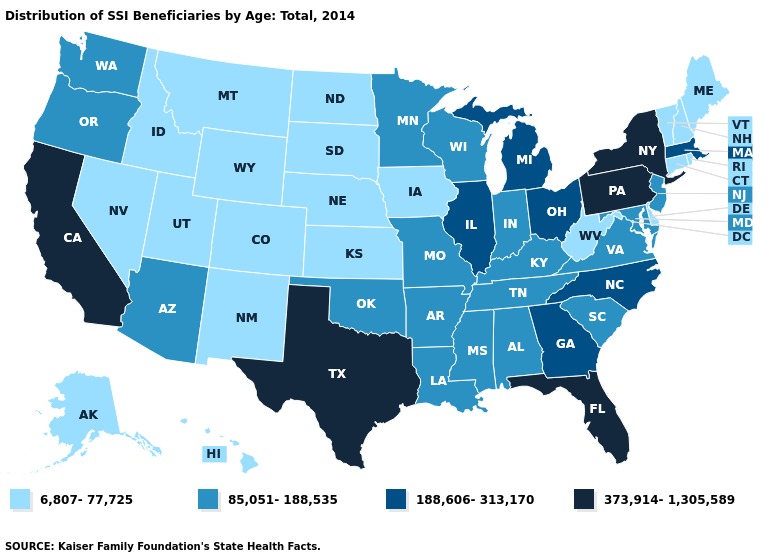Does South Carolina have the lowest value in the USA?
Short answer required. No. What is the value of Oklahoma?
Be succinct. 85,051-188,535. What is the value of Arizona?
Give a very brief answer. 85,051-188,535. What is the highest value in states that border New Hampshire?
Be succinct. 188,606-313,170. How many symbols are there in the legend?
Keep it brief. 4. What is the value of New Hampshire?
Answer briefly. 6,807-77,725. Does South Dakota have a lower value than New Hampshire?
Answer briefly. No. What is the value of Wisconsin?
Quick response, please. 85,051-188,535. What is the highest value in the USA?
Write a very short answer. 373,914-1,305,589. Name the states that have a value in the range 85,051-188,535?
Give a very brief answer. Alabama, Arizona, Arkansas, Indiana, Kentucky, Louisiana, Maryland, Minnesota, Mississippi, Missouri, New Jersey, Oklahoma, Oregon, South Carolina, Tennessee, Virginia, Washington, Wisconsin. Among the states that border Minnesota , which have the highest value?
Quick response, please. Wisconsin. Name the states that have a value in the range 6,807-77,725?
Answer briefly. Alaska, Colorado, Connecticut, Delaware, Hawaii, Idaho, Iowa, Kansas, Maine, Montana, Nebraska, Nevada, New Hampshire, New Mexico, North Dakota, Rhode Island, South Dakota, Utah, Vermont, West Virginia, Wyoming. What is the lowest value in states that border Nebraska?
Short answer required. 6,807-77,725. Which states have the highest value in the USA?
Concise answer only. California, Florida, New York, Pennsylvania, Texas. What is the value of New Hampshire?
Short answer required. 6,807-77,725. 